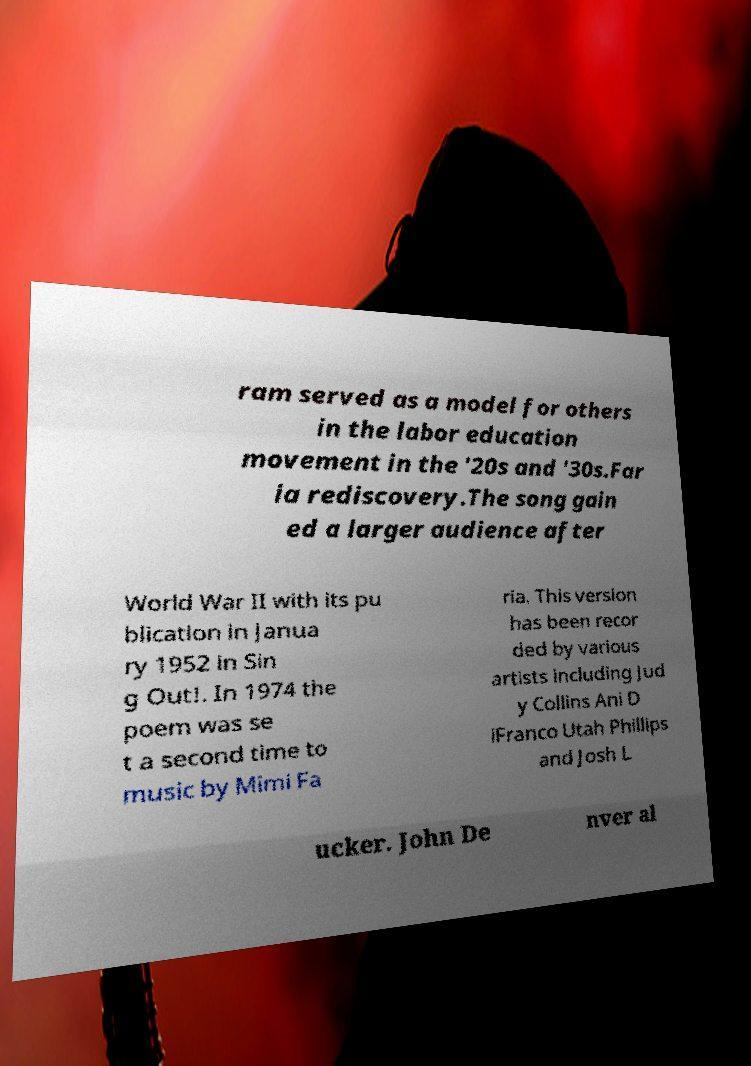Could you assist in decoding the text presented in this image and type it out clearly? ram served as a model for others in the labor education movement in the '20s and '30s.Far ia rediscovery.The song gain ed a larger audience after World War II with its pu blication in Janua ry 1952 in Sin g Out!. In 1974 the poem was se t a second time to music by Mimi Fa ria. This version has been recor ded by various artists including Jud y Collins Ani D iFranco Utah Phillips and Josh L ucker. John De nver al 